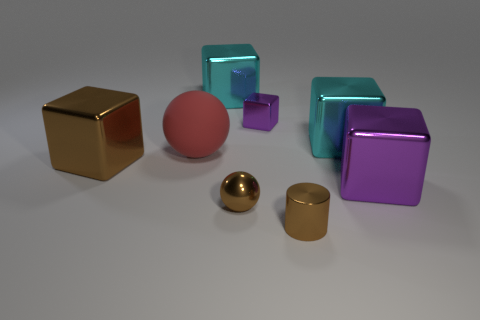Are there any other things that have the same material as the large red ball?
Your answer should be compact. No. There is a ball that is the same size as the cylinder; what color is it?
Offer a very short reply. Brown. The matte ball has what size?
Keep it short and to the point. Large. Is the cyan thing that is left of the tiny metallic cylinder made of the same material as the big red sphere?
Your response must be concise. No. Is the shape of the small purple thing the same as the large purple thing?
Keep it short and to the point. Yes. The large matte object that is in front of the large block behind the purple cube that is left of the large purple metallic thing is what shape?
Provide a succinct answer. Sphere. Do the big cyan metal thing to the right of the tiny cylinder and the brown shiny thing on the left side of the red sphere have the same shape?
Provide a short and direct response. Yes. Are there any big purple spheres made of the same material as the tiny brown sphere?
Offer a very short reply. No. There is a small thing that is to the left of the purple thing behind the large purple shiny object that is to the right of the rubber sphere; what color is it?
Give a very brief answer. Brown. Are the brown thing behind the large purple metal object and the big object in front of the brown metal cube made of the same material?
Give a very brief answer. Yes. 